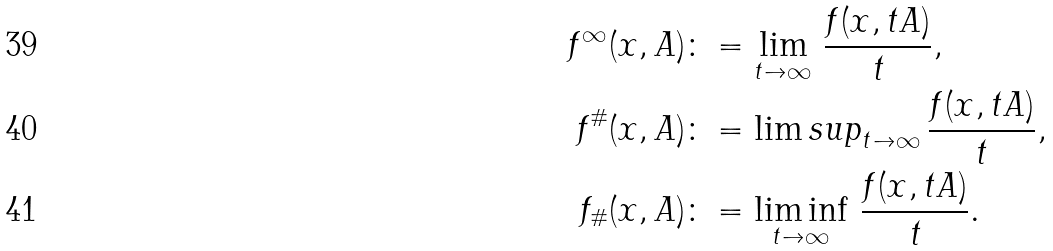Convert formula to latex. <formula><loc_0><loc_0><loc_500><loc_500>f ^ { \infty } ( x , A ) & \colon = \lim _ { \substack { t \to \infty } } \, \frac { f ( x , t A ) } { t } , \\ f ^ { \# } ( x , A ) & \colon = \lim s u p _ { \substack { t \to \infty } } \, \frac { f ( x , t A ) } { t } , \\ f _ { \# } ( x , A ) & \colon = \liminf _ { \substack { t \to \infty } } \, \frac { f ( x , t A ) } { t } .</formula> 